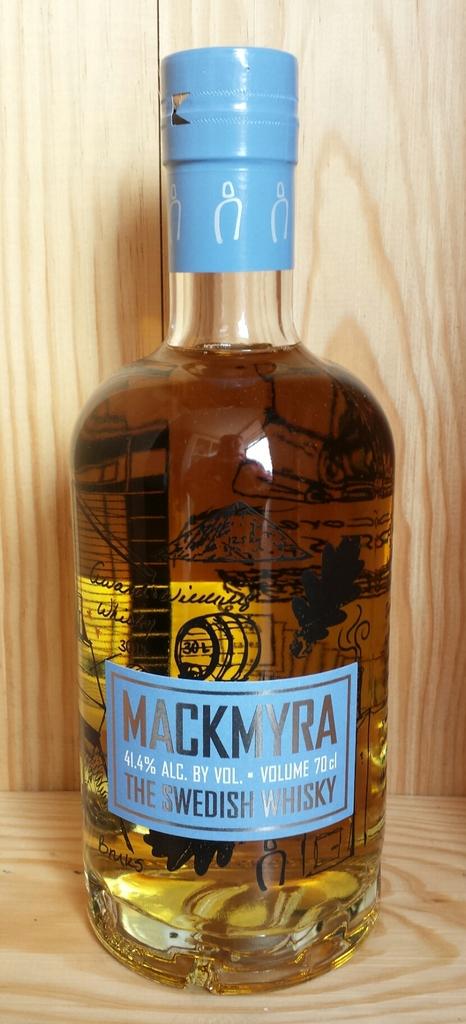What is the % alcohol?
Make the answer very short. 41.4. 